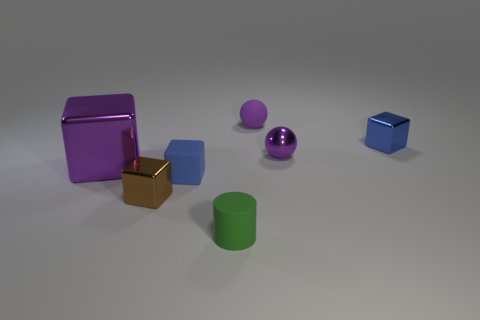What color is the tiny rubber sphere?
Give a very brief answer. Purple. What number of other objects are the same size as the green matte object?
Provide a succinct answer. 5. There is a small brown object that is the same shape as the big purple thing; what is its material?
Your response must be concise. Metal. What material is the small sphere right of the tiny purple sphere that is left of the purple shiny thing on the right side of the brown metallic thing made of?
Offer a terse response. Metal. The blue cube that is made of the same material as the brown object is what size?
Offer a terse response. Small. Are there any other things of the same color as the big block?
Give a very brief answer. Yes. Is the color of the sphere that is in front of the purple matte sphere the same as the tiny shiny block in front of the large thing?
Your answer should be compact. No. What is the color of the metal thing that is in front of the large shiny cube?
Your answer should be compact. Brown. There is a blue object that is to the right of the matte ball; is its size the same as the green cylinder?
Give a very brief answer. Yes. Are there fewer green cylinders than big purple matte cubes?
Provide a short and direct response. No. 